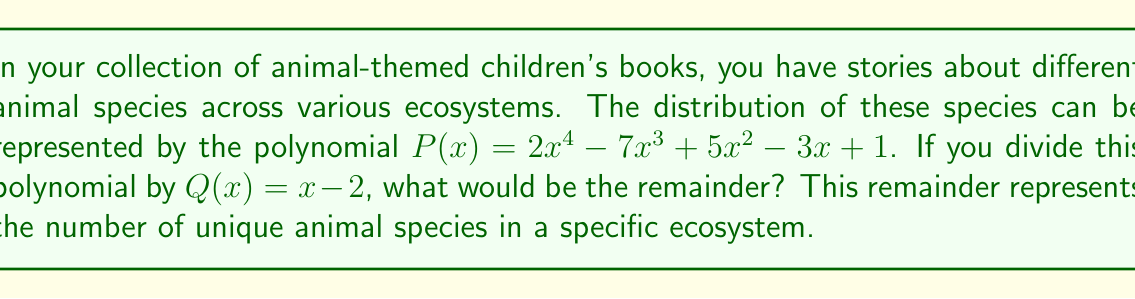Can you answer this question? To find the remainder when dividing $P(x)$ by $Q(x) = x - 2$, we can use the polynomial remainder theorem. This theorem states that the remainder of a polynomial $P(x)$ divided by $x - a$ is equal to $P(a)$.

In this case, $Q(x) = x - 2$, so $a = 2$.

Let's evaluate $P(2)$:

$P(2) = 2(2^4) - 7(2^3) + 5(2^2) - 3(2) + 1$

$= 2(16) - 7(8) + 5(4) - 3(2) + 1$

$= 32 - 56 + 20 - 6 + 1$

$= -9$

Therefore, the remainder when $P(x)$ is divided by $Q(x) = x - 2$ is -9.
Answer: -9 